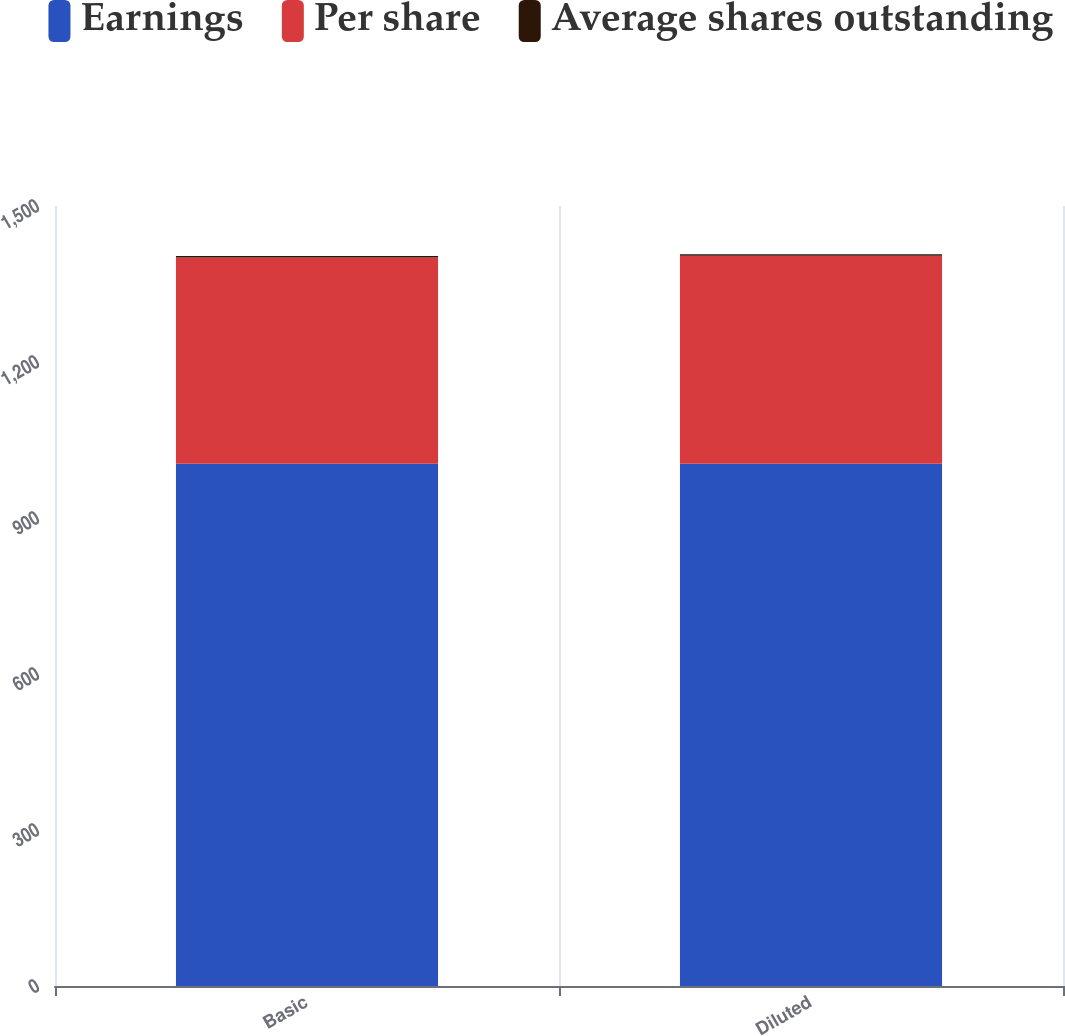Convert chart to OTSL. <chart><loc_0><loc_0><loc_500><loc_500><stacked_bar_chart><ecel><fcel>Basic<fcel>Diluted<nl><fcel>Earnings<fcel>1004.1<fcel>1004.1<nl><fcel>Per share<fcel>397<fcel>400.4<nl><fcel>Average shares outstanding<fcel>2.53<fcel>2.51<nl></chart> 